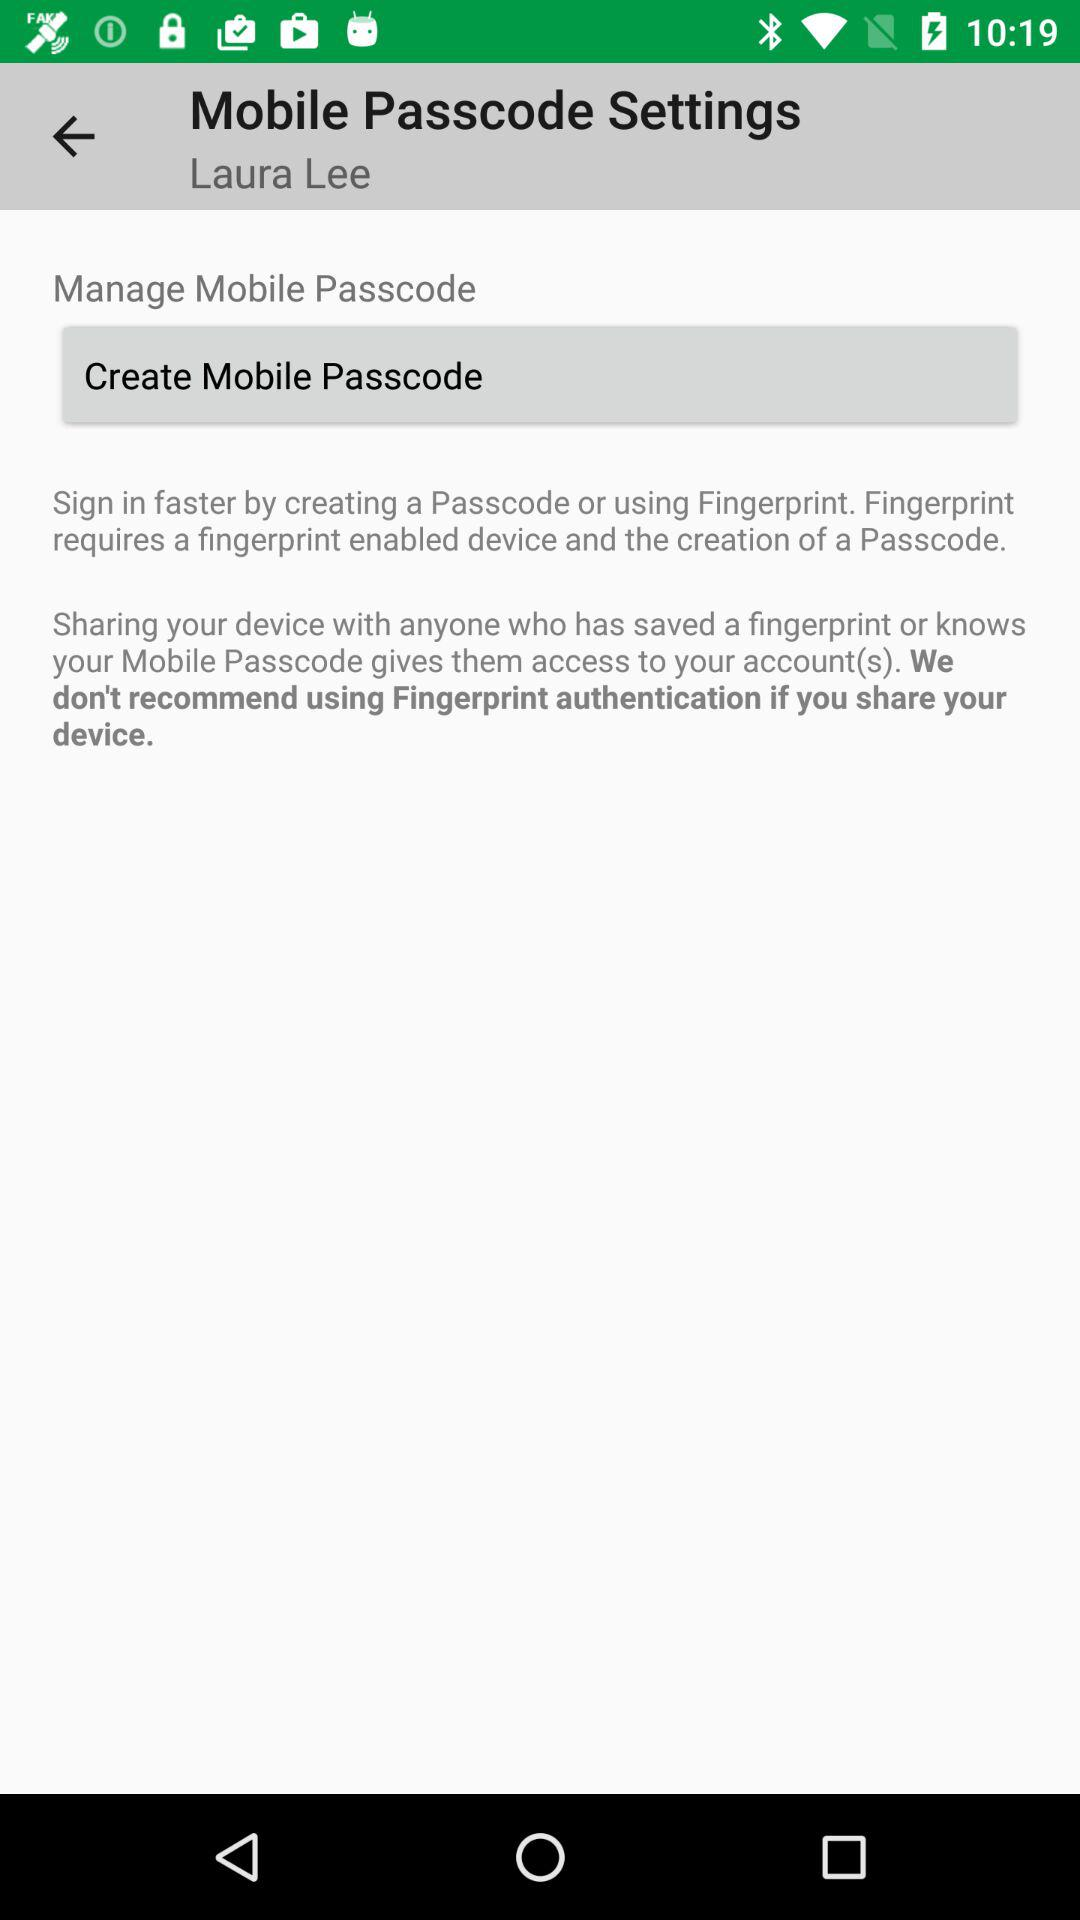What is the given user name? The given user name is Laura Lee. 